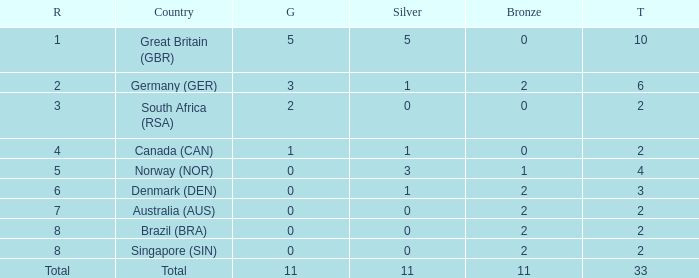What is the least total when the nation is canada (can) and bronze is less than 0? None. 